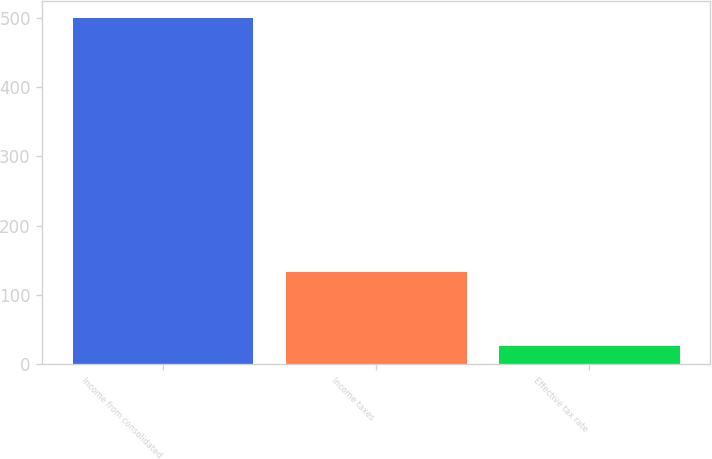<chart> <loc_0><loc_0><loc_500><loc_500><bar_chart><fcel>Income from consolidated<fcel>Income taxes<fcel>Effective tax rate<nl><fcel>499.4<fcel>133.6<fcel>26.8<nl></chart> 